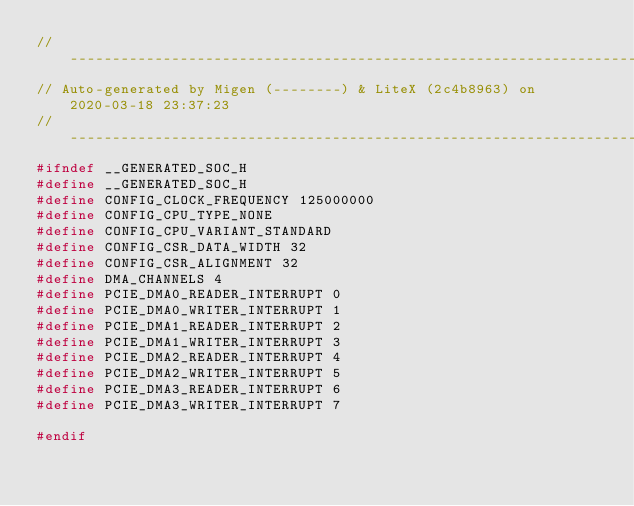<code> <loc_0><loc_0><loc_500><loc_500><_C_>//--------------------------------------------------------------------------------
// Auto-generated by Migen (--------) & LiteX (2c4b8963) on 2020-03-18 23:37:23
//--------------------------------------------------------------------------------
#ifndef __GENERATED_SOC_H
#define __GENERATED_SOC_H
#define CONFIG_CLOCK_FREQUENCY 125000000
#define CONFIG_CPU_TYPE_NONE
#define CONFIG_CPU_VARIANT_STANDARD
#define CONFIG_CSR_DATA_WIDTH 32
#define CONFIG_CSR_ALIGNMENT 32
#define DMA_CHANNELS 4
#define PCIE_DMA0_READER_INTERRUPT 0
#define PCIE_DMA0_WRITER_INTERRUPT 1
#define PCIE_DMA1_READER_INTERRUPT 2
#define PCIE_DMA1_WRITER_INTERRUPT 3
#define PCIE_DMA2_READER_INTERRUPT 4
#define PCIE_DMA2_WRITER_INTERRUPT 5
#define PCIE_DMA3_READER_INTERRUPT 6
#define PCIE_DMA3_WRITER_INTERRUPT 7

#endif
</code> 